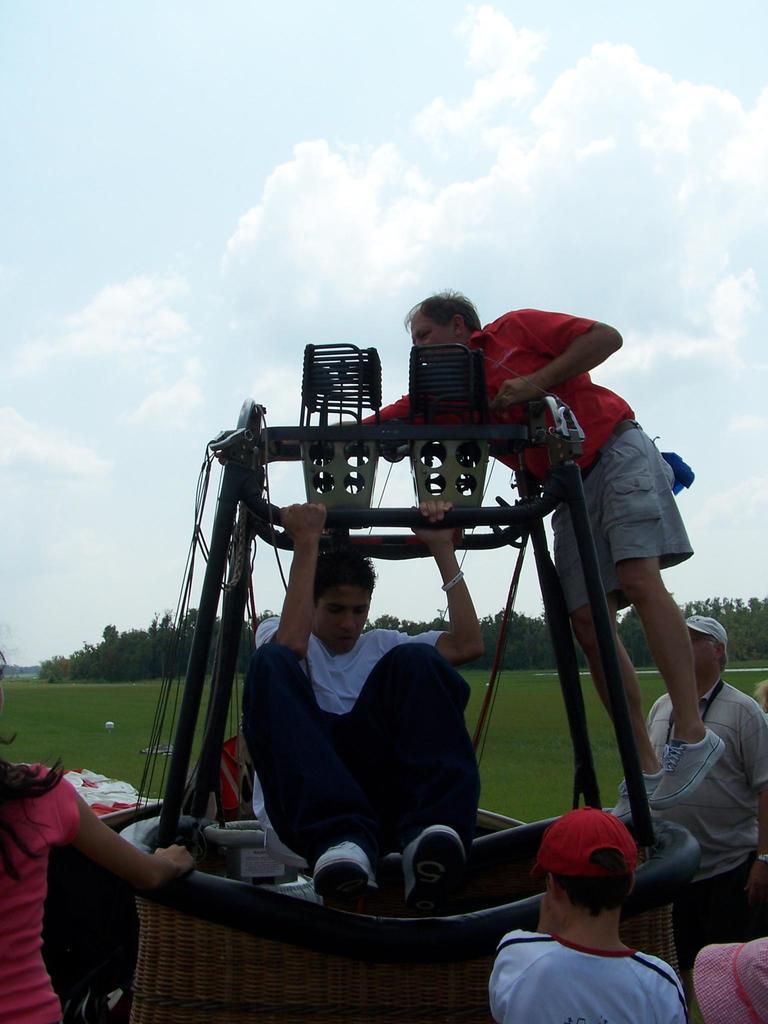How would you summarize this image in a sentence or two? In this image there is a man who is jumping out from the parachute basket. There are few people around the basket. On the right side there is a person standing on the basket and holding the ropes. In the background there are trees. At the top there is the sky. On the left side there is a woman. In front of the woman there is a table. 